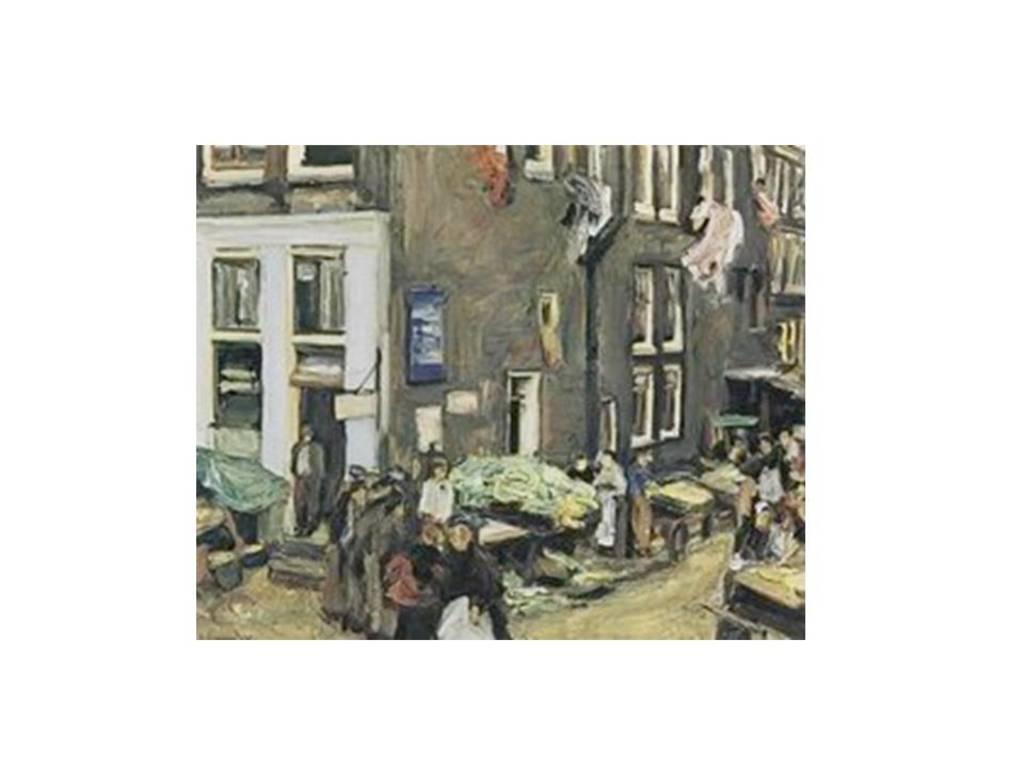Can you describe this image briefly? In this picture I can see a painting of building, people and some other objects. 